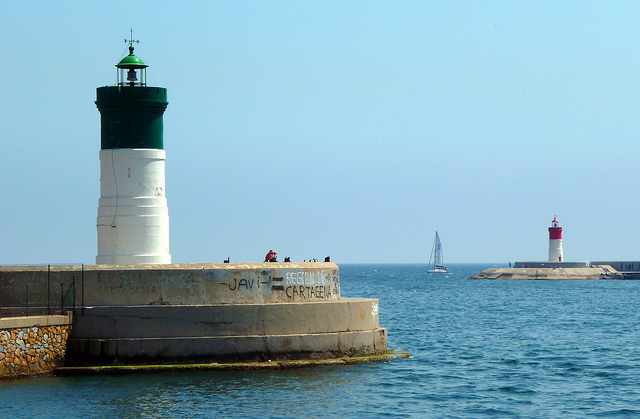Read all the text in this image. Javi CARTAEEM 